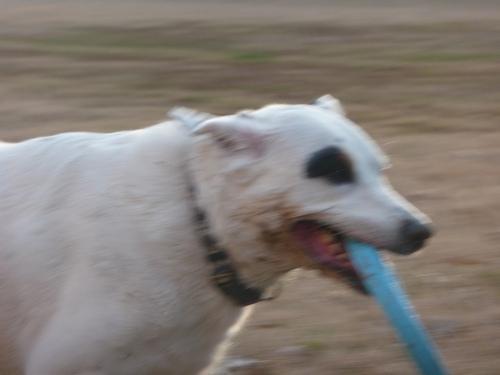How many dogs are there?
Give a very brief answer. 1. How many sticks?
Give a very brief answer. 1. 